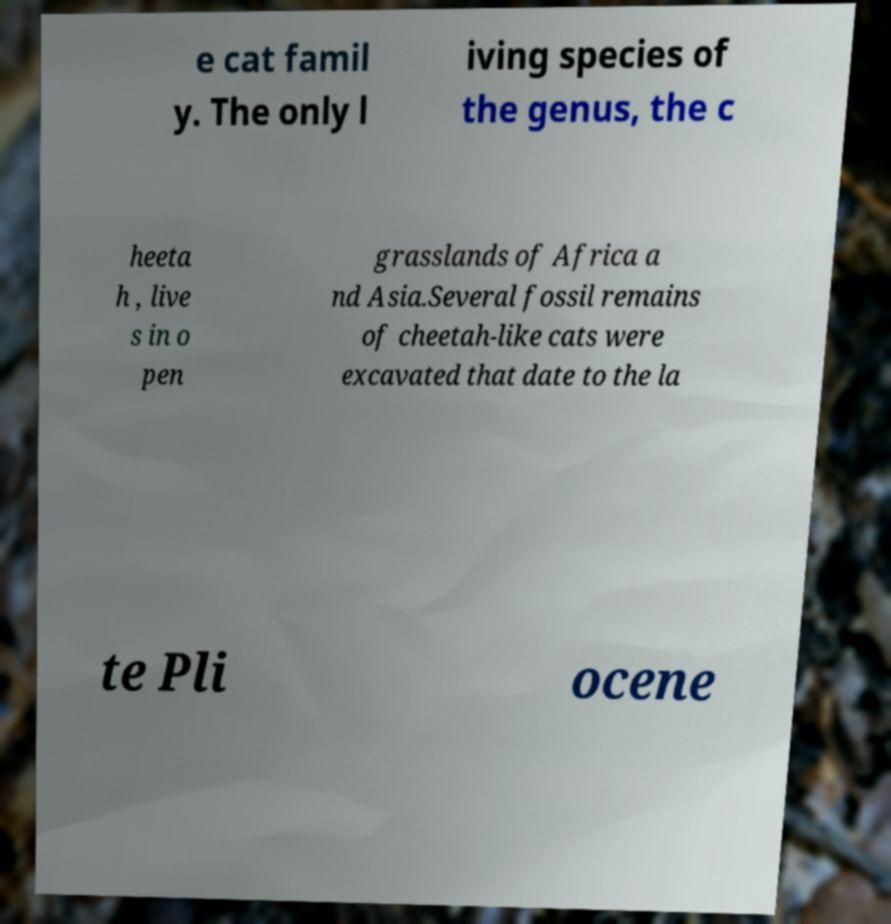What messages or text are displayed in this image? I need them in a readable, typed format. e cat famil y. The only l iving species of the genus, the c heeta h , live s in o pen grasslands of Africa a nd Asia.Several fossil remains of cheetah-like cats were excavated that date to the la te Pli ocene 